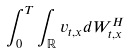<formula> <loc_0><loc_0><loc_500><loc_500>\int _ { 0 } ^ { T } \int _ { \mathbb { R } } v _ { t , x } d W _ { t , x } ^ { H }</formula> 